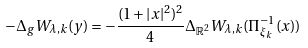Convert formula to latex. <formula><loc_0><loc_0><loc_500><loc_500>- \Delta _ { g } W _ { \lambda , k } ( y ) = - \frac { ( 1 + | x | ^ { 2 } ) ^ { 2 } } { 4 } \Delta _ { \mathbb { R } ^ { 2 } } W _ { \lambda , k } ( \Pi ^ { - 1 } _ { \xi _ { k } } ( x ) )</formula> 